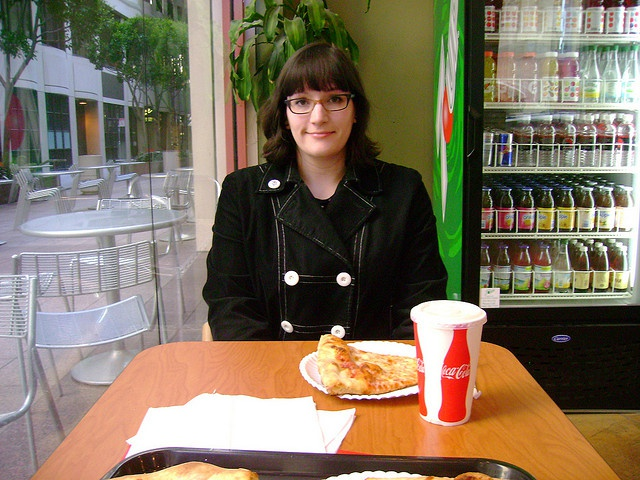Describe the objects in this image and their specific colors. I can see refrigerator in black, darkgray, ivory, and gray tones, dining table in black, white, salmon, and orange tones, people in black, maroon, brown, and lightpink tones, bottle in black, darkgray, ivory, and gray tones, and chair in black, darkgray, and lavender tones in this image. 